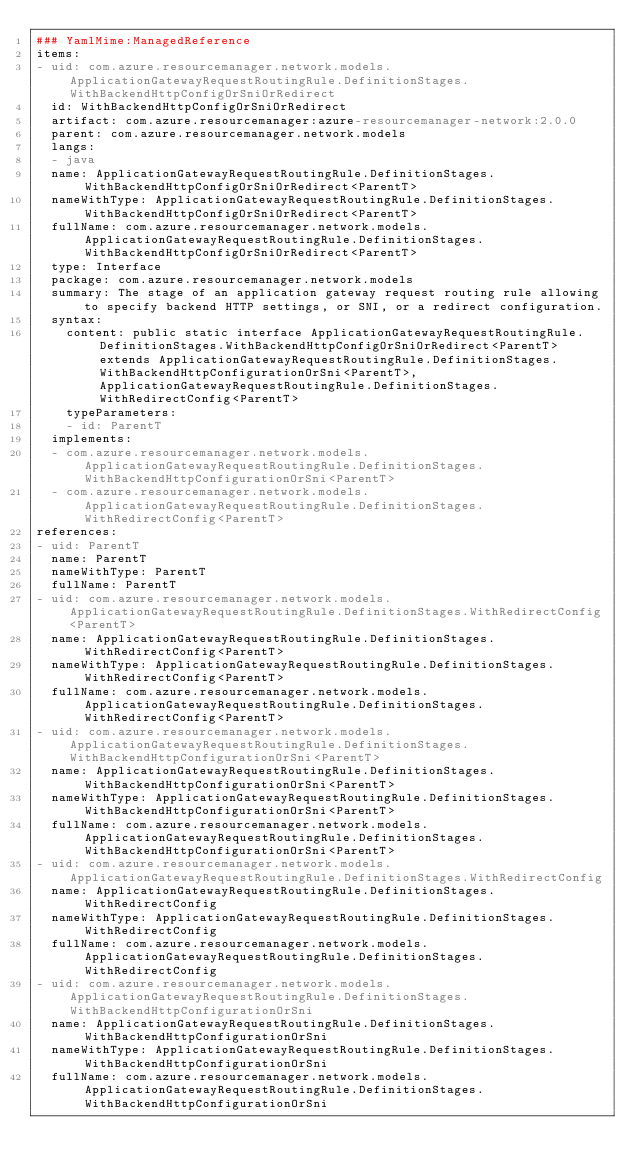Convert code to text. <code><loc_0><loc_0><loc_500><loc_500><_YAML_>### YamlMime:ManagedReference
items:
- uid: com.azure.resourcemanager.network.models.ApplicationGatewayRequestRoutingRule.DefinitionStages.WithBackendHttpConfigOrSniOrRedirect
  id: WithBackendHttpConfigOrSniOrRedirect
  artifact: com.azure.resourcemanager:azure-resourcemanager-network:2.0.0
  parent: com.azure.resourcemanager.network.models
  langs:
  - java
  name: ApplicationGatewayRequestRoutingRule.DefinitionStages.WithBackendHttpConfigOrSniOrRedirect<ParentT>
  nameWithType: ApplicationGatewayRequestRoutingRule.DefinitionStages.WithBackendHttpConfigOrSniOrRedirect<ParentT>
  fullName: com.azure.resourcemanager.network.models.ApplicationGatewayRequestRoutingRule.DefinitionStages.WithBackendHttpConfigOrSniOrRedirect<ParentT>
  type: Interface
  package: com.azure.resourcemanager.network.models
  summary: The stage of an application gateway request routing rule allowing to specify backend HTTP settings, or SNI, or a redirect configuration.
  syntax:
    content: public static interface ApplicationGatewayRequestRoutingRule.DefinitionStages.WithBackendHttpConfigOrSniOrRedirect<ParentT> extends ApplicationGatewayRequestRoutingRule.DefinitionStages.WithBackendHttpConfigurationOrSni<ParentT>, ApplicationGatewayRequestRoutingRule.DefinitionStages.WithRedirectConfig<ParentT>
    typeParameters:
    - id: ParentT
  implements:
  - com.azure.resourcemanager.network.models.ApplicationGatewayRequestRoutingRule.DefinitionStages.WithBackendHttpConfigurationOrSni<ParentT>
  - com.azure.resourcemanager.network.models.ApplicationGatewayRequestRoutingRule.DefinitionStages.WithRedirectConfig<ParentT>
references:
- uid: ParentT
  name: ParentT
  nameWithType: ParentT
  fullName: ParentT
- uid: com.azure.resourcemanager.network.models.ApplicationGatewayRequestRoutingRule.DefinitionStages.WithRedirectConfig<ParentT>
  name: ApplicationGatewayRequestRoutingRule.DefinitionStages.WithRedirectConfig<ParentT>
  nameWithType: ApplicationGatewayRequestRoutingRule.DefinitionStages.WithRedirectConfig<ParentT>
  fullName: com.azure.resourcemanager.network.models.ApplicationGatewayRequestRoutingRule.DefinitionStages.WithRedirectConfig<ParentT>
- uid: com.azure.resourcemanager.network.models.ApplicationGatewayRequestRoutingRule.DefinitionStages.WithBackendHttpConfigurationOrSni<ParentT>
  name: ApplicationGatewayRequestRoutingRule.DefinitionStages.WithBackendHttpConfigurationOrSni<ParentT>
  nameWithType: ApplicationGatewayRequestRoutingRule.DefinitionStages.WithBackendHttpConfigurationOrSni<ParentT>
  fullName: com.azure.resourcemanager.network.models.ApplicationGatewayRequestRoutingRule.DefinitionStages.WithBackendHttpConfigurationOrSni<ParentT>
- uid: com.azure.resourcemanager.network.models.ApplicationGatewayRequestRoutingRule.DefinitionStages.WithRedirectConfig
  name: ApplicationGatewayRequestRoutingRule.DefinitionStages.WithRedirectConfig
  nameWithType: ApplicationGatewayRequestRoutingRule.DefinitionStages.WithRedirectConfig
  fullName: com.azure.resourcemanager.network.models.ApplicationGatewayRequestRoutingRule.DefinitionStages.WithRedirectConfig
- uid: com.azure.resourcemanager.network.models.ApplicationGatewayRequestRoutingRule.DefinitionStages.WithBackendHttpConfigurationOrSni
  name: ApplicationGatewayRequestRoutingRule.DefinitionStages.WithBackendHttpConfigurationOrSni
  nameWithType: ApplicationGatewayRequestRoutingRule.DefinitionStages.WithBackendHttpConfigurationOrSni
  fullName: com.azure.resourcemanager.network.models.ApplicationGatewayRequestRoutingRule.DefinitionStages.WithBackendHttpConfigurationOrSni
</code> 